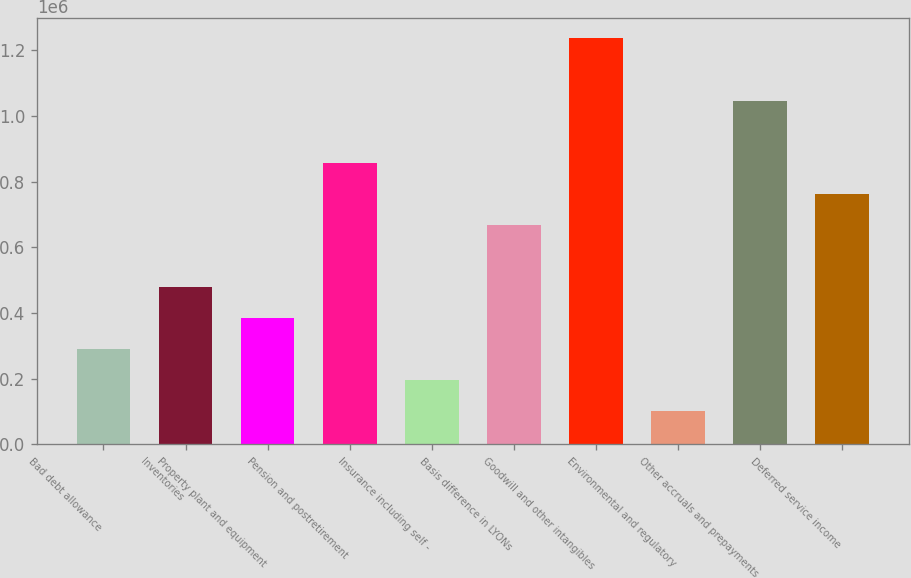<chart> <loc_0><loc_0><loc_500><loc_500><bar_chart><fcel>Bad debt allowance<fcel>Inventories<fcel>Property plant and equipment<fcel>Pension and postretirement<fcel>Insurance including self -<fcel>Basis difference in LYONs<fcel>Goodwill and other intangibles<fcel>Environmental and regulatory<fcel>Other accruals and prepayments<fcel>Deferred service income<nl><fcel>291304<fcel>480218<fcel>385761<fcel>858047<fcel>196846<fcel>669132<fcel>1.23588e+06<fcel>102389<fcel>1.04696e+06<fcel>763590<nl></chart> 